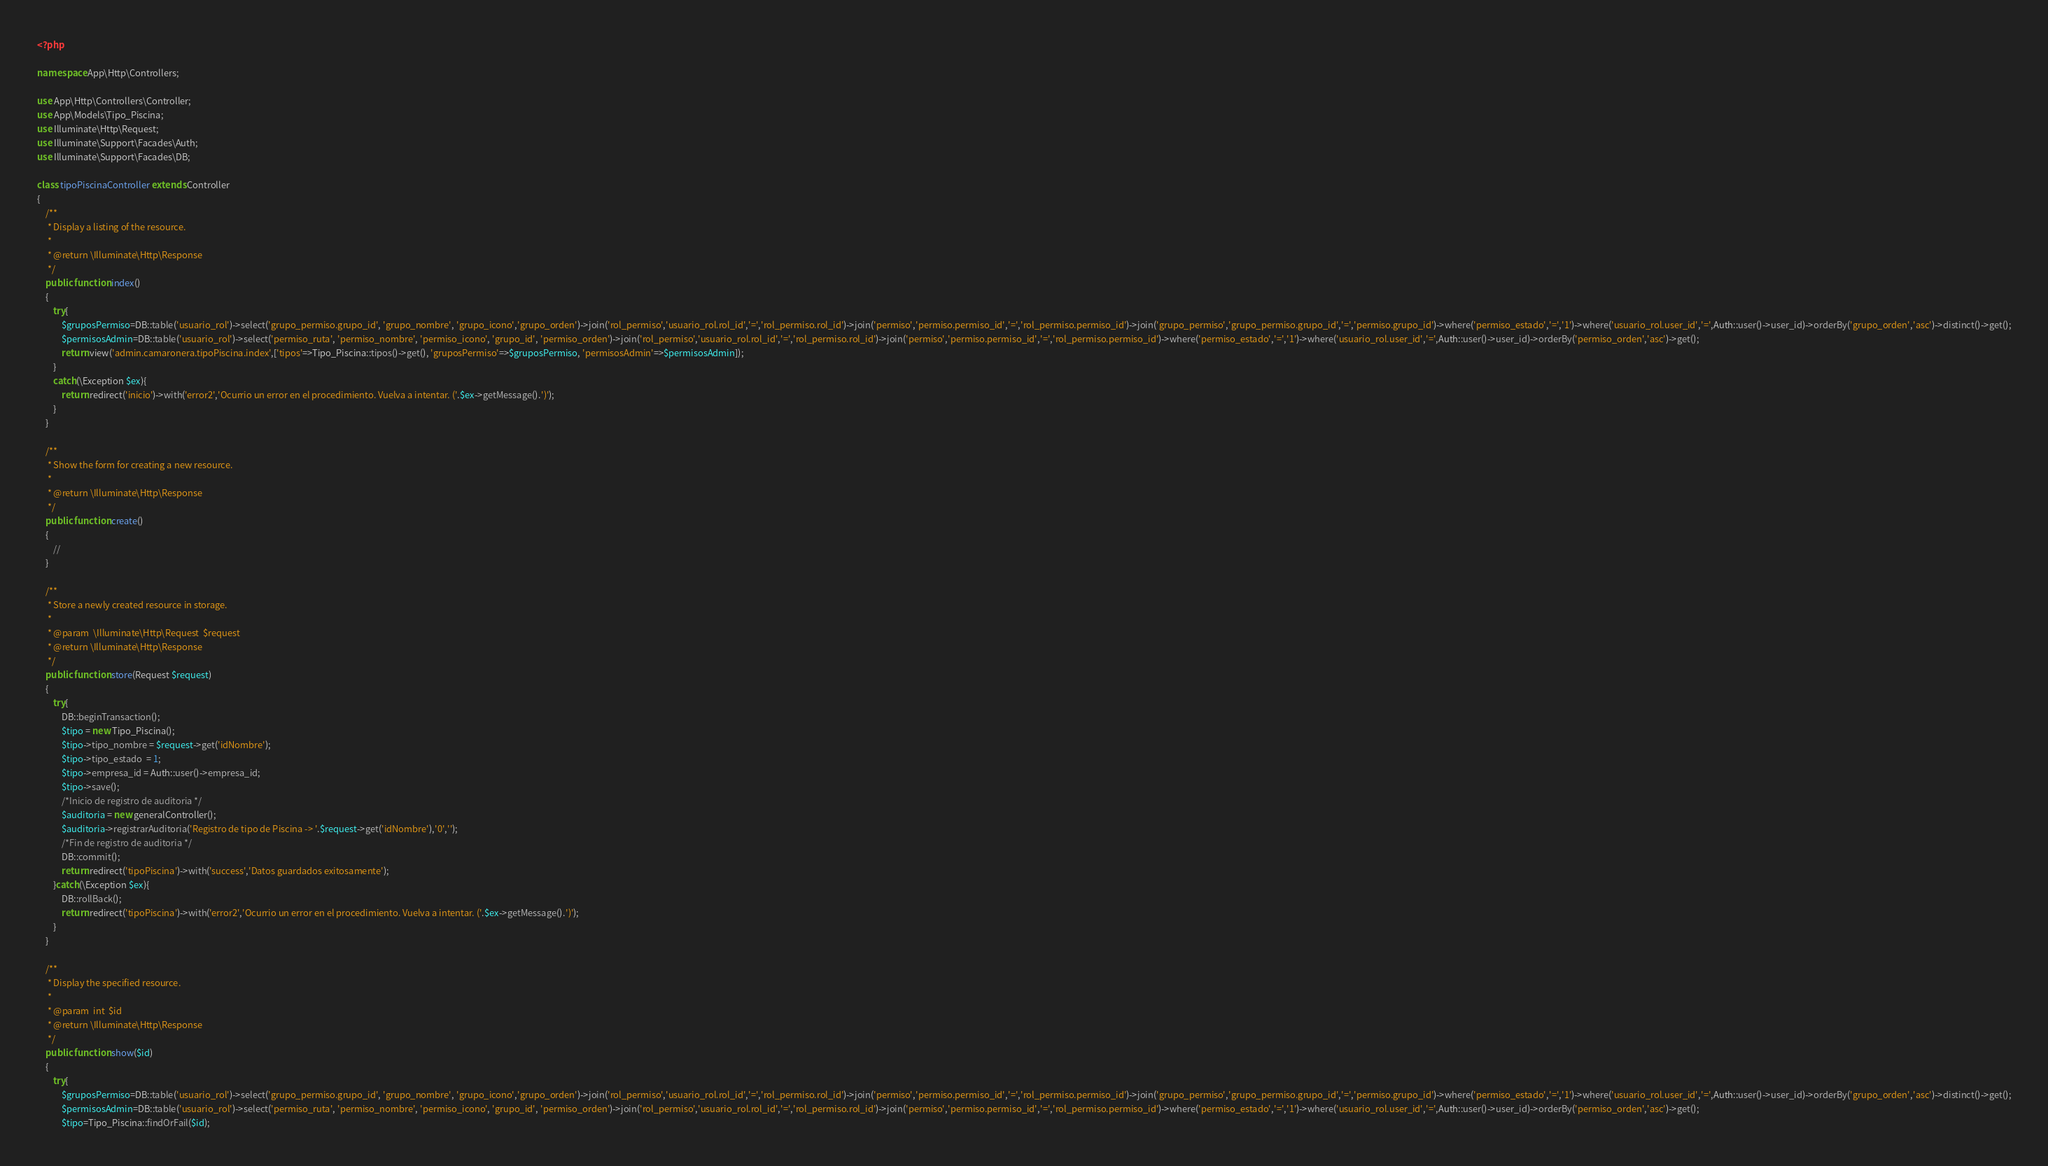<code> <loc_0><loc_0><loc_500><loc_500><_PHP_><?php

namespace App\Http\Controllers;

use App\Http\Controllers\Controller;
use App\Models\Tipo_Piscina;
use Illuminate\Http\Request;
use Illuminate\Support\Facades\Auth;
use Illuminate\Support\Facades\DB;

class tipoPiscinaController extends Controller
{
    /**
     * Display a listing of the resource.
     *
     * @return \Illuminate\Http\Response
     */
    public function index()
    {
        try{
            $gruposPermiso=DB::table('usuario_rol')->select('grupo_permiso.grupo_id', 'grupo_nombre', 'grupo_icono','grupo_orden')->join('rol_permiso','usuario_rol.rol_id','=','rol_permiso.rol_id')->join('permiso','permiso.permiso_id','=','rol_permiso.permiso_id')->join('grupo_permiso','grupo_permiso.grupo_id','=','permiso.grupo_id')->where('permiso_estado','=','1')->where('usuario_rol.user_id','=',Auth::user()->user_id)->orderBy('grupo_orden','asc')->distinct()->get();
            $permisosAdmin=DB::table('usuario_rol')->select('permiso_ruta', 'permiso_nombre', 'permiso_icono', 'grupo_id', 'permiso_orden')->join('rol_permiso','usuario_rol.rol_id','=','rol_permiso.rol_id')->join('permiso','permiso.permiso_id','=','rol_permiso.permiso_id')->where('permiso_estado','=','1')->where('usuario_rol.user_id','=',Auth::user()->user_id)->orderBy('permiso_orden','asc')->get();        
            return view('admin.camaronera.tipoPiscina.index',['tipos'=>Tipo_Piscina::tipos()->get(), 'gruposPermiso'=>$gruposPermiso, 'permisosAdmin'=>$permisosAdmin]);
        }
        catch(\Exception $ex){      
            return redirect('inicio')->with('error2','Ocurrio un error en el procedimiento. Vuelva a intentar. ('.$ex->getMessage().')');
        }
    }

    /**
     * Show the form for creating a new resource.
     *
     * @return \Illuminate\Http\Response
     */
    public function create()
    {
        //
    }

    /**
     * Store a newly created resource in storage.
     *
     * @param  \Illuminate\Http\Request  $request
     * @return \Illuminate\Http\Response
     */
    public function store(Request $request)
    {
        try{
            DB::beginTransaction();
            $tipo = new Tipo_Piscina();
            $tipo->tipo_nombre = $request->get('idNombre');             
            $tipo->tipo_estado  = 1;
            $tipo->empresa_id = Auth::user()->empresa_id;       
            $tipo->save();
            /*Inicio de registro de auditoria */
            $auditoria = new generalController();
            $auditoria->registrarAuditoria('Registro de tipo de Piscina -> '.$request->get('idNombre'),'0','');
            /*Fin de registro de auditoria */
            DB::commit();
            return redirect('tipoPiscina')->with('success','Datos guardados exitosamente');
        }catch(\Exception $ex){
            DB::rollBack();
            return redirect('tipoPiscina')->with('error2','Ocurrio un error en el procedimiento. Vuelva a intentar. ('.$ex->getMessage().')');
        }
    }

    /**
     * Display the specified resource.
     *
     * @param  int  $id
     * @return \Illuminate\Http\Response
     */
    public function show($id)
    {
        try{
            $gruposPermiso=DB::table('usuario_rol')->select('grupo_permiso.grupo_id', 'grupo_nombre', 'grupo_icono','grupo_orden')->join('rol_permiso','usuario_rol.rol_id','=','rol_permiso.rol_id')->join('permiso','permiso.permiso_id','=','rol_permiso.permiso_id')->join('grupo_permiso','grupo_permiso.grupo_id','=','permiso.grupo_id')->where('permiso_estado','=','1')->where('usuario_rol.user_id','=',Auth::user()->user_id)->orderBy('grupo_orden','asc')->distinct()->get();
            $permisosAdmin=DB::table('usuario_rol')->select('permiso_ruta', 'permiso_nombre', 'permiso_icono', 'grupo_id', 'permiso_orden')->join('rol_permiso','usuario_rol.rol_id','=','rol_permiso.rol_id')->join('permiso','permiso.permiso_id','=','rol_permiso.permiso_id')->where('permiso_estado','=','1')->where('usuario_rol.user_id','=',Auth::user()->user_id)->orderBy('permiso_orden','asc')->get();
            $tipo=Tipo_Piscina::findOrFail($id);  </code> 